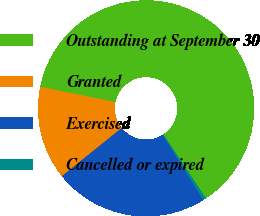<chart> <loc_0><loc_0><loc_500><loc_500><pie_chart><fcel>Outstanding at September 30<fcel>Granted<fcel>Exercised<fcel>Cancelled or expired<nl><fcel>62.46%<fcel>13.98%<fcel>23.12%<fcel>0.44%<nl></chart> 